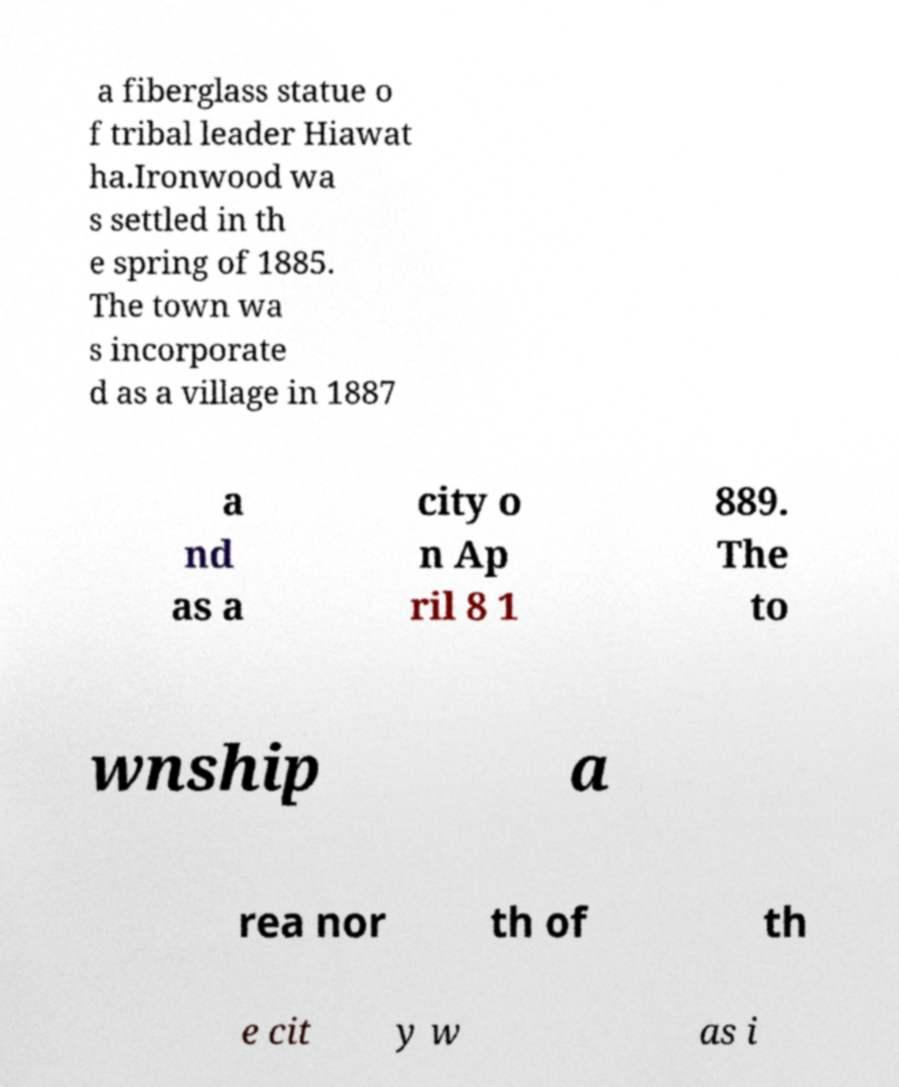Please identify and transcribe the text found in this image. a fiberglass statue o f tribal leader Hiawat ha.Ironwood wa s settled in th e spring of 1885. The town wa s incorporate d as a village in 1887 a nd as a city o n Ap ril 8 1 889. The to wnship a rea nor th of th e cit y w as i 